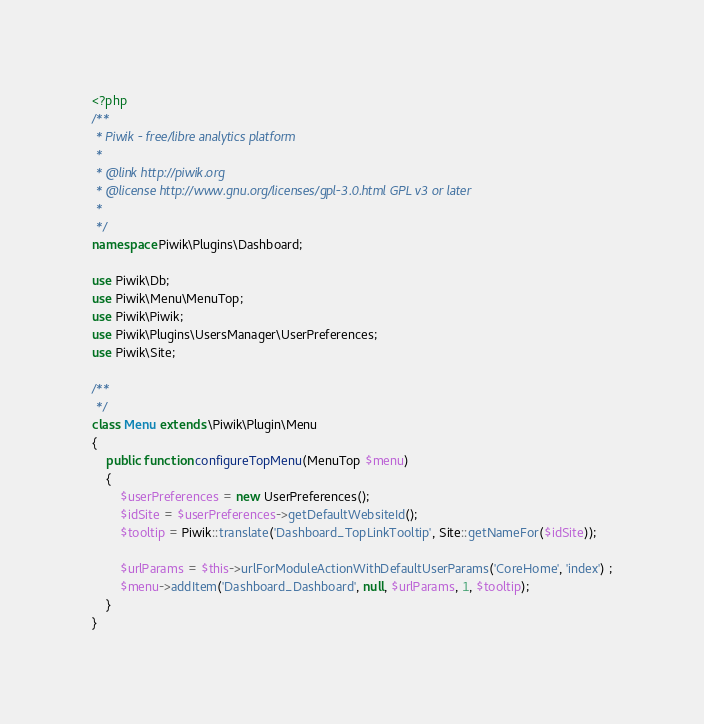Convert code to text. <code><loc_0><loc_0><loc_500><loc_500><_PHP_><?php
/**
 * Piwik - free/libre analytics platform
 *
 * @link http://piwik.org
 * @license http://www.gnu.org/licenses/gpl-3.0.html GPL v3 or later
 *
 */
namespace Piwik\Plugins\Dashboard;

use Piwik\Db;
use Piwik\Menu\MenuTop;
use Piwik\Piwik;
use Piwik\Plugins\UsersManager\UserPreferences;
use Piwik\Site;

/**
 */
class Menu extends \Piwik\Plugin\Menu
{
    public function configureTopMenu(MenuTop $menu)
    {
        $userPreferences = new UserPreferences();
        $idSite = $userPreferences->getDefaultWebsiteId();
        $tooltip = Piwik::translate('Dashboard_TopLinkTooltip', Site::getNameFor($idSite));

        $urlParams = $this->urlForModuleActionWithDefaultUserParams('CoreHome', 'index') ;
        $menu->addItem('Dashboard_Dashboard', null, $urlParams, 1, $tooltip);
    }
}

</code> 